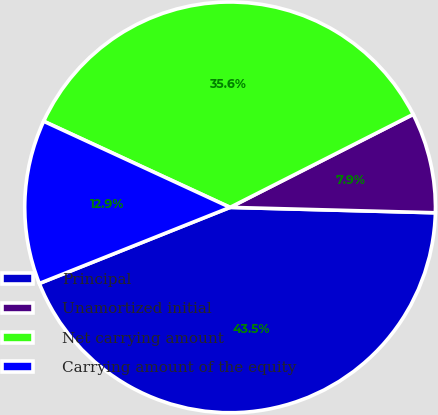Convert chart to OTSL. <chart><loc_0><loc_0><loc_500><loc_500><pie_chart><fcel>Principal<fcel>Unamortized initial<fcel>Net carrying amount<fcel>Carrying amount of the equity<nl><fcel>43.54%<fcel>7.9%<fcel>35.63%<fcel>12.93%<nl></chart> 